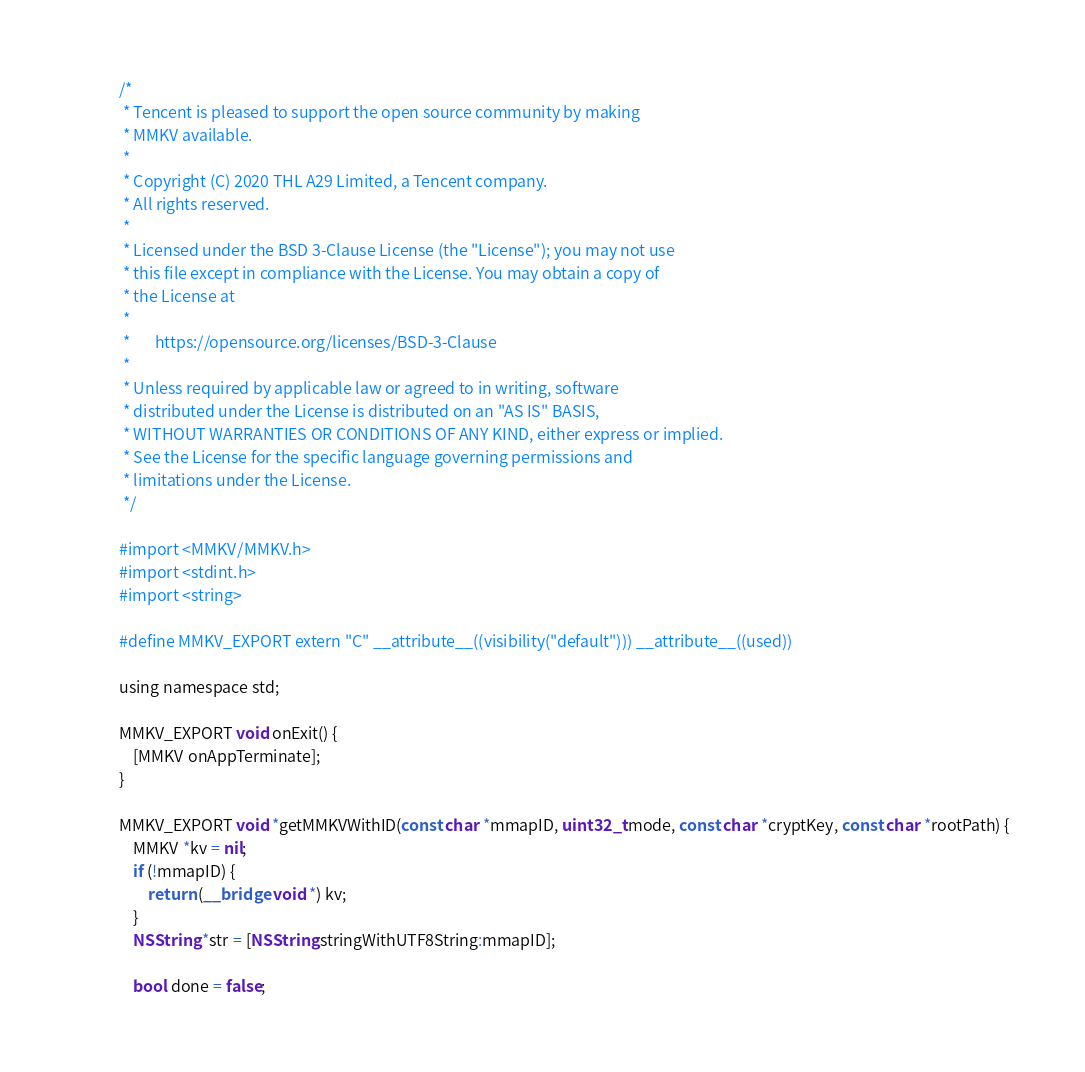<code> <loc_0><loc_0><loc_500><loc_500><_ObjectiveC_>/*
 * Tencent is pleased to support the open source community by making
 * MMKV available.
 *
 * Copyright (C) 2020 THL A29 Limited, a Tencent company.
 * All rights reserved.
 *
 * Licensed under the BSD 3-Clause License (the "License"); you may not use
 * this file except in compliance with the License. You may obtain a copy of
 * the License at
 *
 *       https://opensource.org/licenses/BSD-3-Clause
 *
 * Unless required by applicable law or agreed to in writing, software
 * distributed under the License is distributed on an "AS IS" BASIS,
 * WITHOUT WARRANTIES OR CONDITIONS OF ANY KIND, either express or implied.
 * See the License for the specific language governing permissions and
 * limitations under the License.
 */

#import <MMKV/MMKV.h>
#import <stdint.h>
#import <string>

#define MMKV_EXPORT extern "C" __attribute__((visibility("default"))) __attribute__((used))

using namespace std;

MMKV_EXPORT void onExit() {
    [MMKV onAppTerminate];
}

MMKV_EXPORT void *getMMKVWithID(const char *mmapID, uint32_t mode, const char *cryptKey, const char *rootPath) {
    MMKV *kv = nil;
    if (!mmapID) {
        return (__bridge void *) kv;
    }
    NSString *str = [NSString stringWithUTF8String:mmapID];

    bool done = false;</code> 